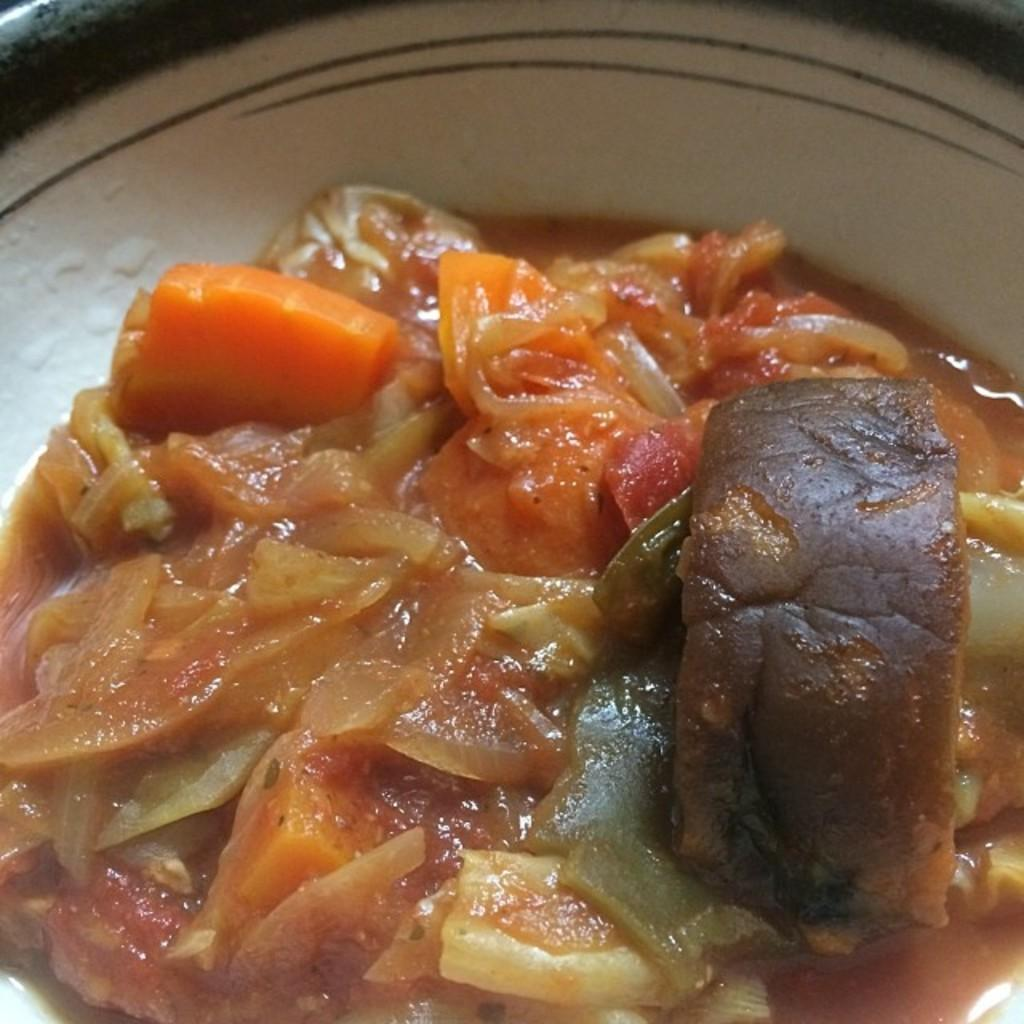What is the color of the object in the image? The object in the image is white. What is inside the object? The object contains a food item. Where is the object located in the image? The object is in the center of the image. How does the kite fly in the image? There is no kite present in the image. What type of jellyfish can be seen swimming in the image? There is no jellyfish present in the image. 